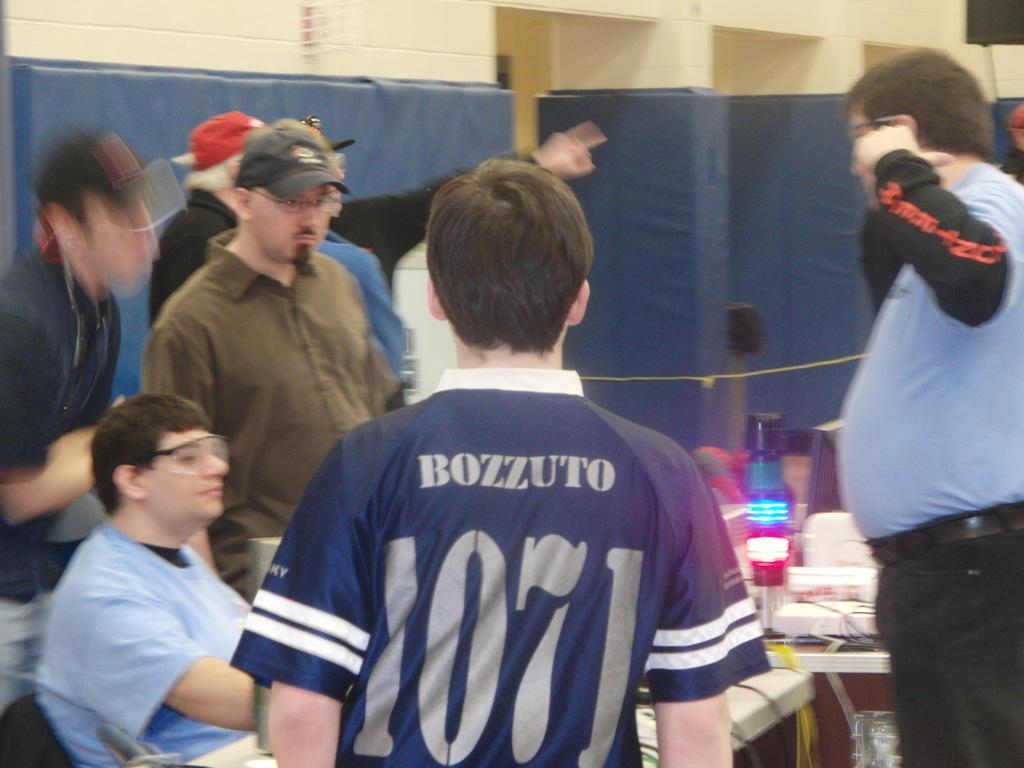<image>
Describe the image concisely. Men having a conversation with one wearing a Bozzuto jersey with the number 1071. 